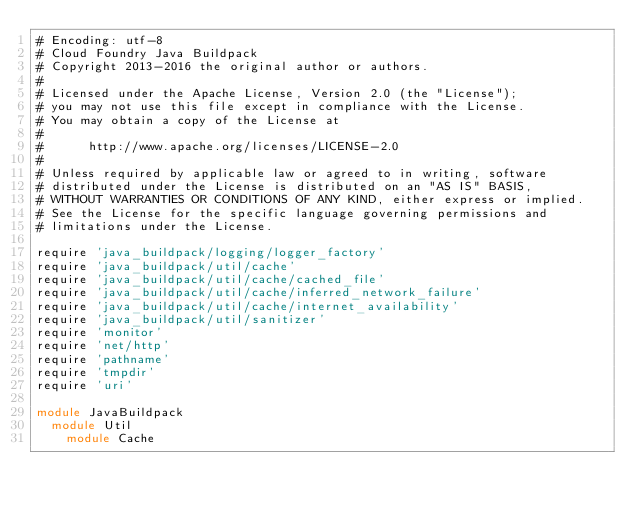Convert code to text. <code><loc_0><loc_0><loc_500><loc_500><_Ruby_># Encoding: utf-8
# Cloud Foundry Java Buildpack
# Copyright 2013-2016 the original author or authors.
#
# Licensed under the Apache License, Version 2.0 (the "License");
# you may not use this file except in compliance with the License.
# You may obtain a copy of the License at
#
#      http://www.apache.org/licenses/LICENSE-2.0
#
# Unless required by applicable law or agreed to in writing, software
# distributed under the License is distributed on an "AS IS" BASIS,
# WITHOUT WARRANTIES OR CONDITIONS OF ANY KIND, either express or implied.
# See the License for the specific language governing permissions and
# limitations under the License.

require 'java_buildpack/logging/logger_factory'
require 'java_buildpack/util/cache'
require 'java_buildpack/util/cache/cached_file'
require 'java_buildpack/util/cache/inferred_network_failure'
require 'java_buildpack/util/cache/internet_availability'
require 'java_buildpack/util/sanitizer'
require 'monitor'
require 'net/http'
require 'pathname'
require 'tmpdir'
require 'uri'

module JavaBuildpack
  module Util
    module Cache
</code> 